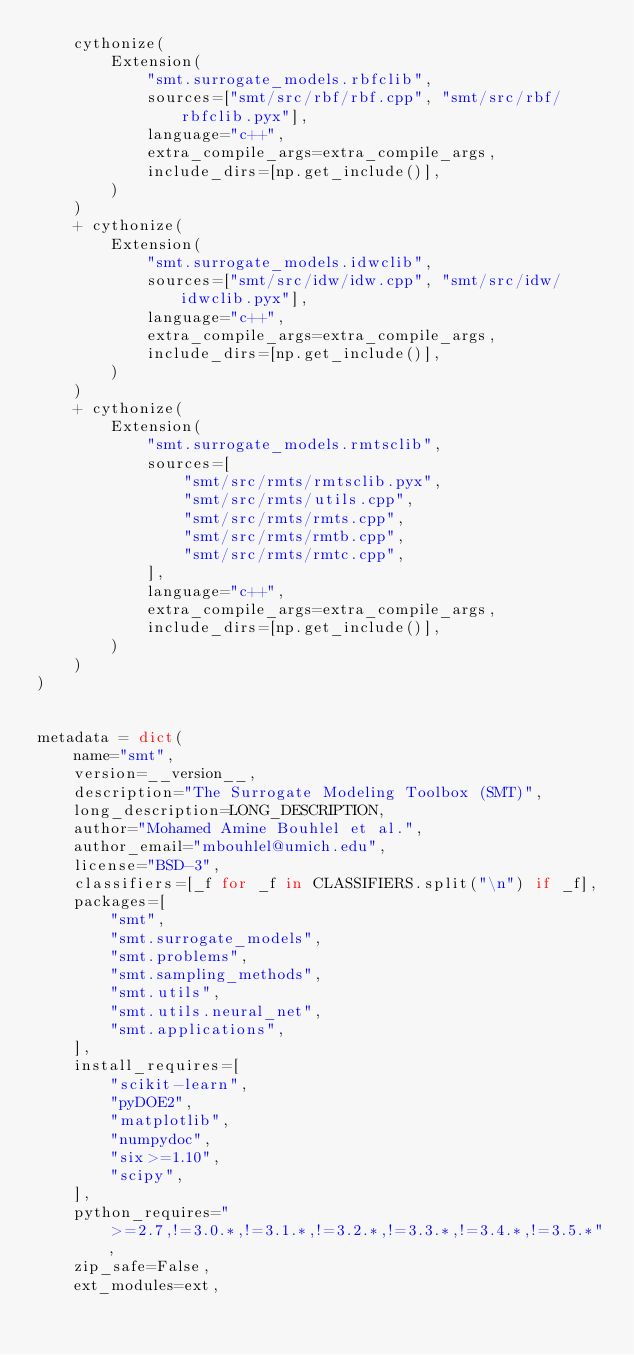Convert code to text. <code><loc_0><loc_0><loc_500><loc_500><_Python_>    cythonize(
        Extension(
            "smt.surrogate_models.rbfclib",
            sources=["smt/src/rbf/rbf.cpp", "smt/src/rbf/rbfclib.pyx"],
            language="c++",
            extra_compile_args=extra_compile_args,
            include_dirs=[np.get_include()],
        )
    )
    + cythonize(
        Extension(
            "smt.surrogate_models.idwclib",
            sources=["smt/src/idw/idw.cpp", "smt/src/idw/idwclib.pyx"],
            language="c++",
            extra_compile_args=extra_compile_args,
            include_dirs=[np.get_include()],
        )
    )
    + cythonize(
        Extension(
            "smt.surrogate_models.rmtsclib",
            sources=[
                "smt/src/rmts/rmtsclib.pyx",
                "smt/src/rmts/utils.cpp",
                "smt/src/rmts/rmts.cpp",
                "smt/src/rmts/rmtb.cpp",
                "smt/src/rmts/rmtc.cpp",
            ],
            language="c++",
            extra_compile_args=extra_compile_args,
            include_dirs=[np.get_include()],
        )
    )
)


metadata = dict(
    name="smt",
    version=__version__,
    description="The Surrogate Modeling Toolbox (SMT)",
    long_description=LONG_DESCRIPTION,
    author="Mohamed Amine Bouhlel et al.",
    author_email="mbouhlel@umich.edu",
    license="BSD-3",
    classifiers=[_f for _f in CLASSIFIERS.split("\n") if _f],
    packages=[
        "smt",
        "smt.surrogate_models",
        "smt.problems",
        "smt.sampling_methods",
        "smt.utils",
        "smt.utils.neural_net",
        "smt.applications",
    ],
    install_requires=[
        "scikit-learn",
        "pyDOE2",
        "matplotlib",
        "numpydoc",
        "six>=1.10",
        "scipy",
    ],
    python_requires=">=2.7,!=3.0.*,!=3.1.*,!=3.2.*,!=3.3.*,!=3.4.*,!=3.5.*",
    zip_safe=False,
    ext_modules=ext,</code> 